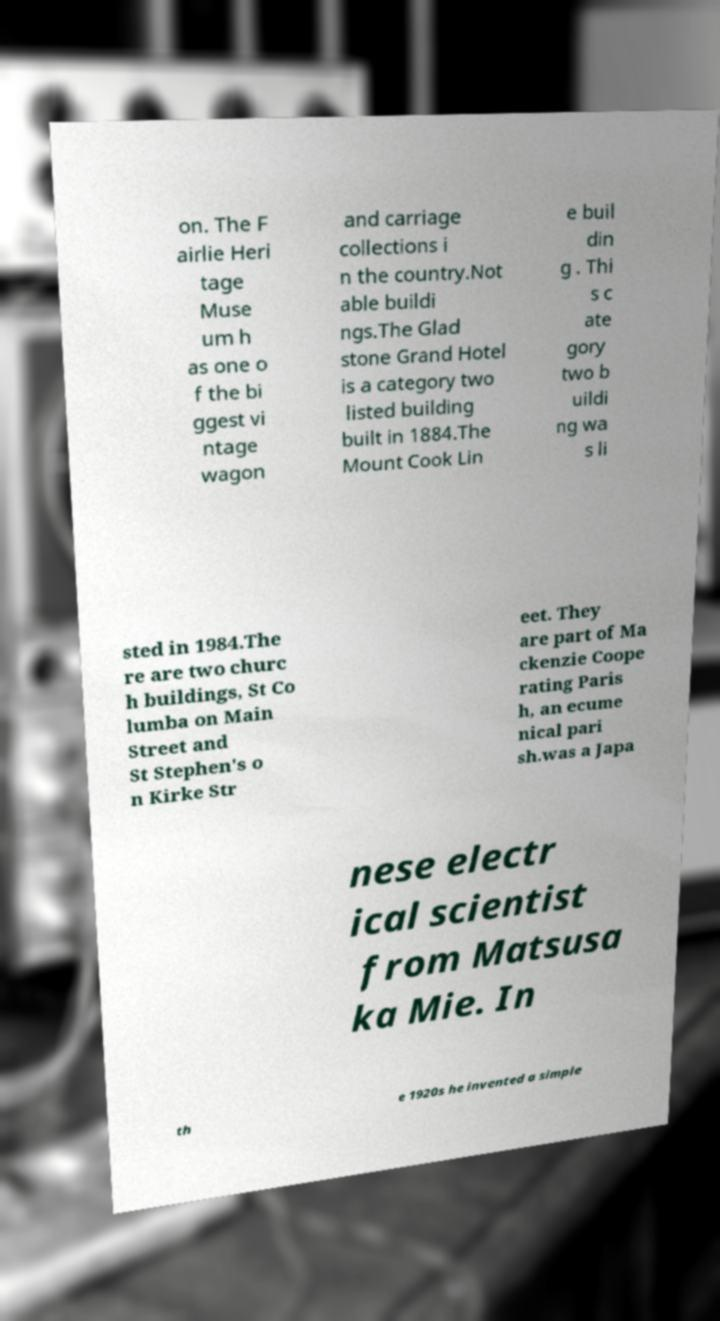Can you read and provide the text displayed in the image?This photo seems to have some interesting text. Can you extract and type it out for me? on. The F airlie Heri tage Muse um h as one o f the bi ggest vi ntage wagon and carriage collections i n the country.Not able buildi ngs.The Glad stone Grand Hotel is a category two listed building built in 1884.The Mount Cook Lin e buil din g . Thi s c ate gory two b uildi ng wa s li sted in 1984.The re are two churc h buildings, St Co lumba on Main Street and St Stephen's o n Kirke Str eet. They are part of Ma ckenzie Coope rating Paris h, an ecume nical pari sh.was a Japa nese electr ical scientist from Matsusa ka Mie. In th e 1920s he invented a simple 